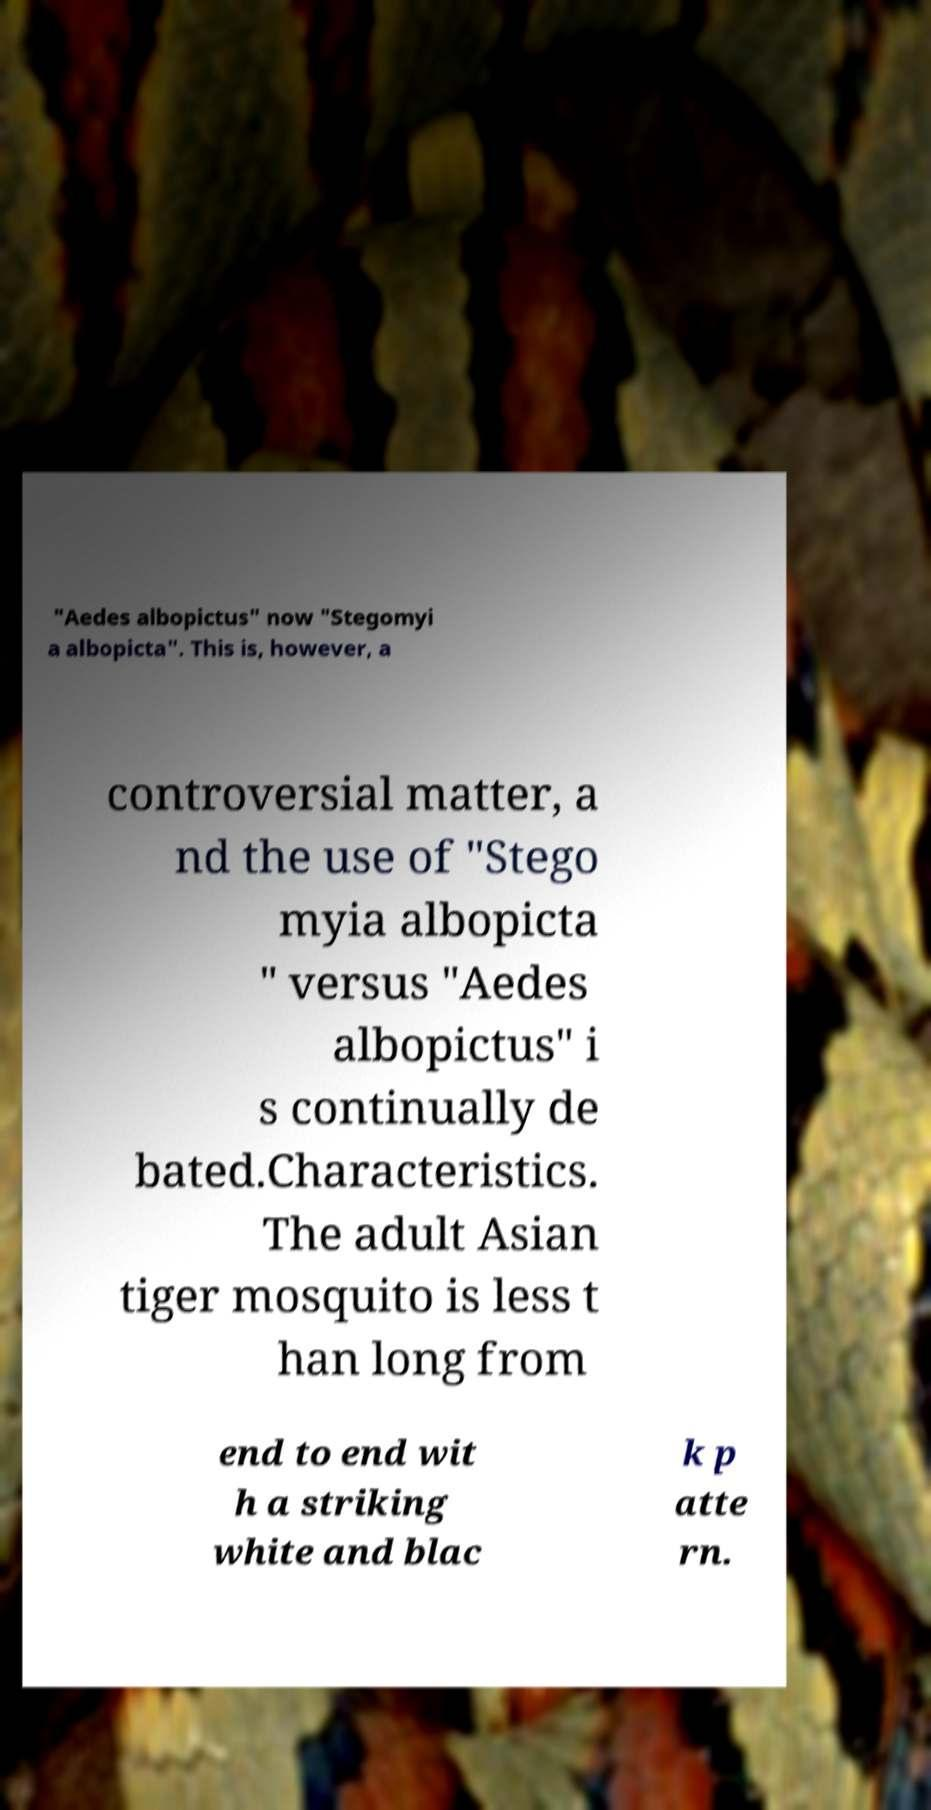What messages or text are displayed in this image? I need them in a readable, typed format. "Aedes albopictus" now "Stegomyi a albopicta". This is, however, a controversial matter, a nd the use of "Stego myia albopicta " versus "Aedes albopictus" i s continually de bated.Characteristics. The adult Asian tiger mosquito is less t han long from end to end wit h a striking white and blac k p atte rn. 